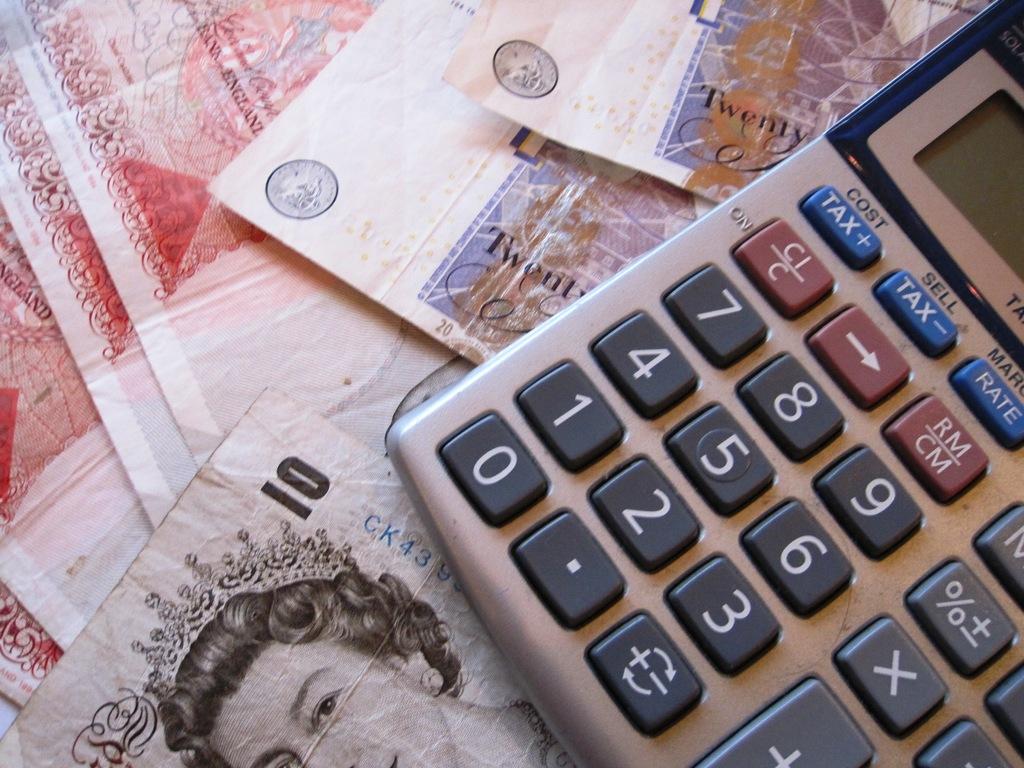What is the word above the tax button?
Offer a terse response. Cost. How much is on the table?
Provide a succinct answer. Unanswerable. 